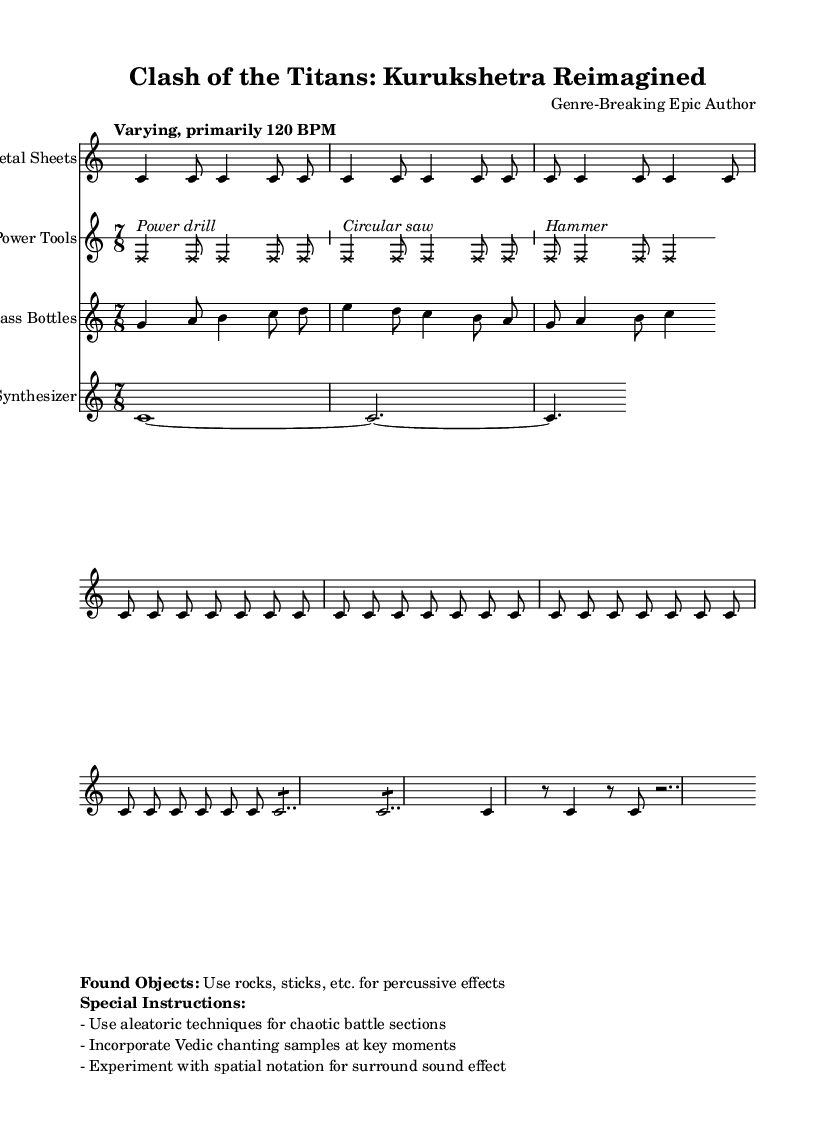What is the time signature of this music? The time signature is indicated at the beginning of the score as 7/8, which is the rhythmic structure the piece follows throughout.
Answer: 7/8 What is the tempo marking for the piece? The tempo is stated as "Varying, primarily 120 BPM," which provides guidance on the overall speed of the piece.
Answer: Varying, primarily 120 BPM How many different instruments are used in this score? The score includes four distinct instruments, each represented by different staves: Metal Sheets, Power Tools, Glass Bottles, and Synthesizer.
Answer: Four What kind of notation is used for the Power Tools staff? The Power Tools staff uses graphic notation with specific symbols like crosses for note heads, which suggests a non-traditional approach to representing sound.
Answer: Graphic notation What is the main motif represented in the Metal Sheets? The main motif consists of alternating bass drum patterns that create a percussive foundation for the battle theme.
Answer: Bass drum patterns What special techniques are recommended for the chaotic sections? The instructions mention the use of aleatoric techniques, which incorporate elements of chance, making the performance unpredictable and dynamic.
Answer: Aleatoric techniques What is suggested to be incorporated at key moments in the piece? The instructions advise incorporating Vedic chanting samples at significant points in the music, enhancing the cultural context and emotional depth of the soundtrack.
Answer: Vedic chanting samples 